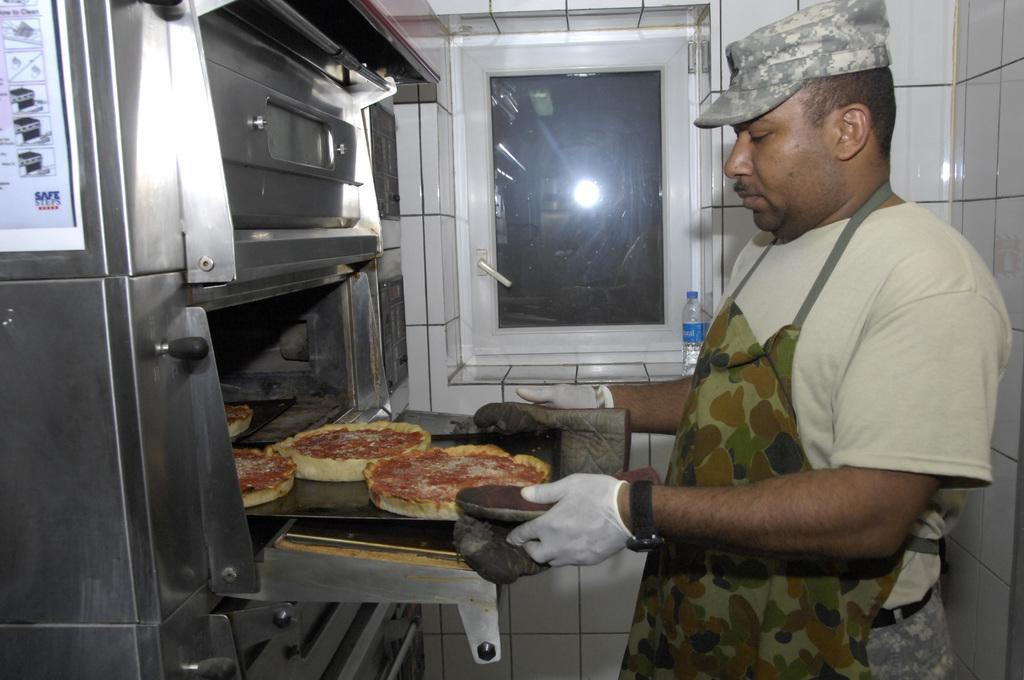<image>
Provide a brief description of the given image. Man cooking some pizza by a sign that tells the Safe Steps. 